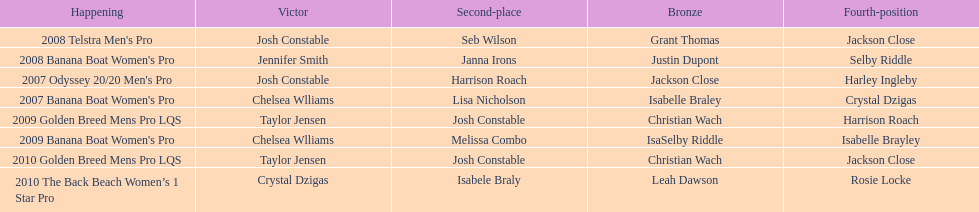List all the years when taylor jensen emerged victorious. 2009, 2010. 